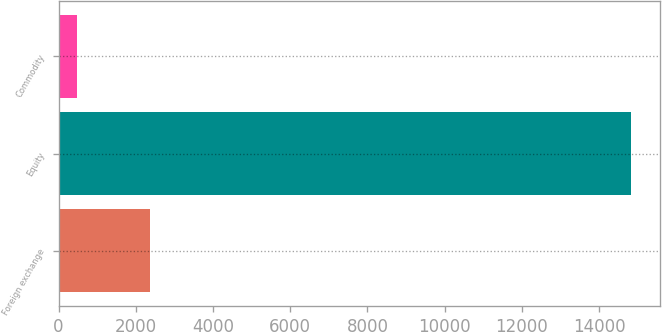Convert chart. <chart><loc_0><loc_0><loc_500><loc_500><bar_chart><fcel>Foreign exchange<fcel>Equity<fcel>Commodity<nl><fcel>2365<fcel>14831<fcel>488<nl></chart> 